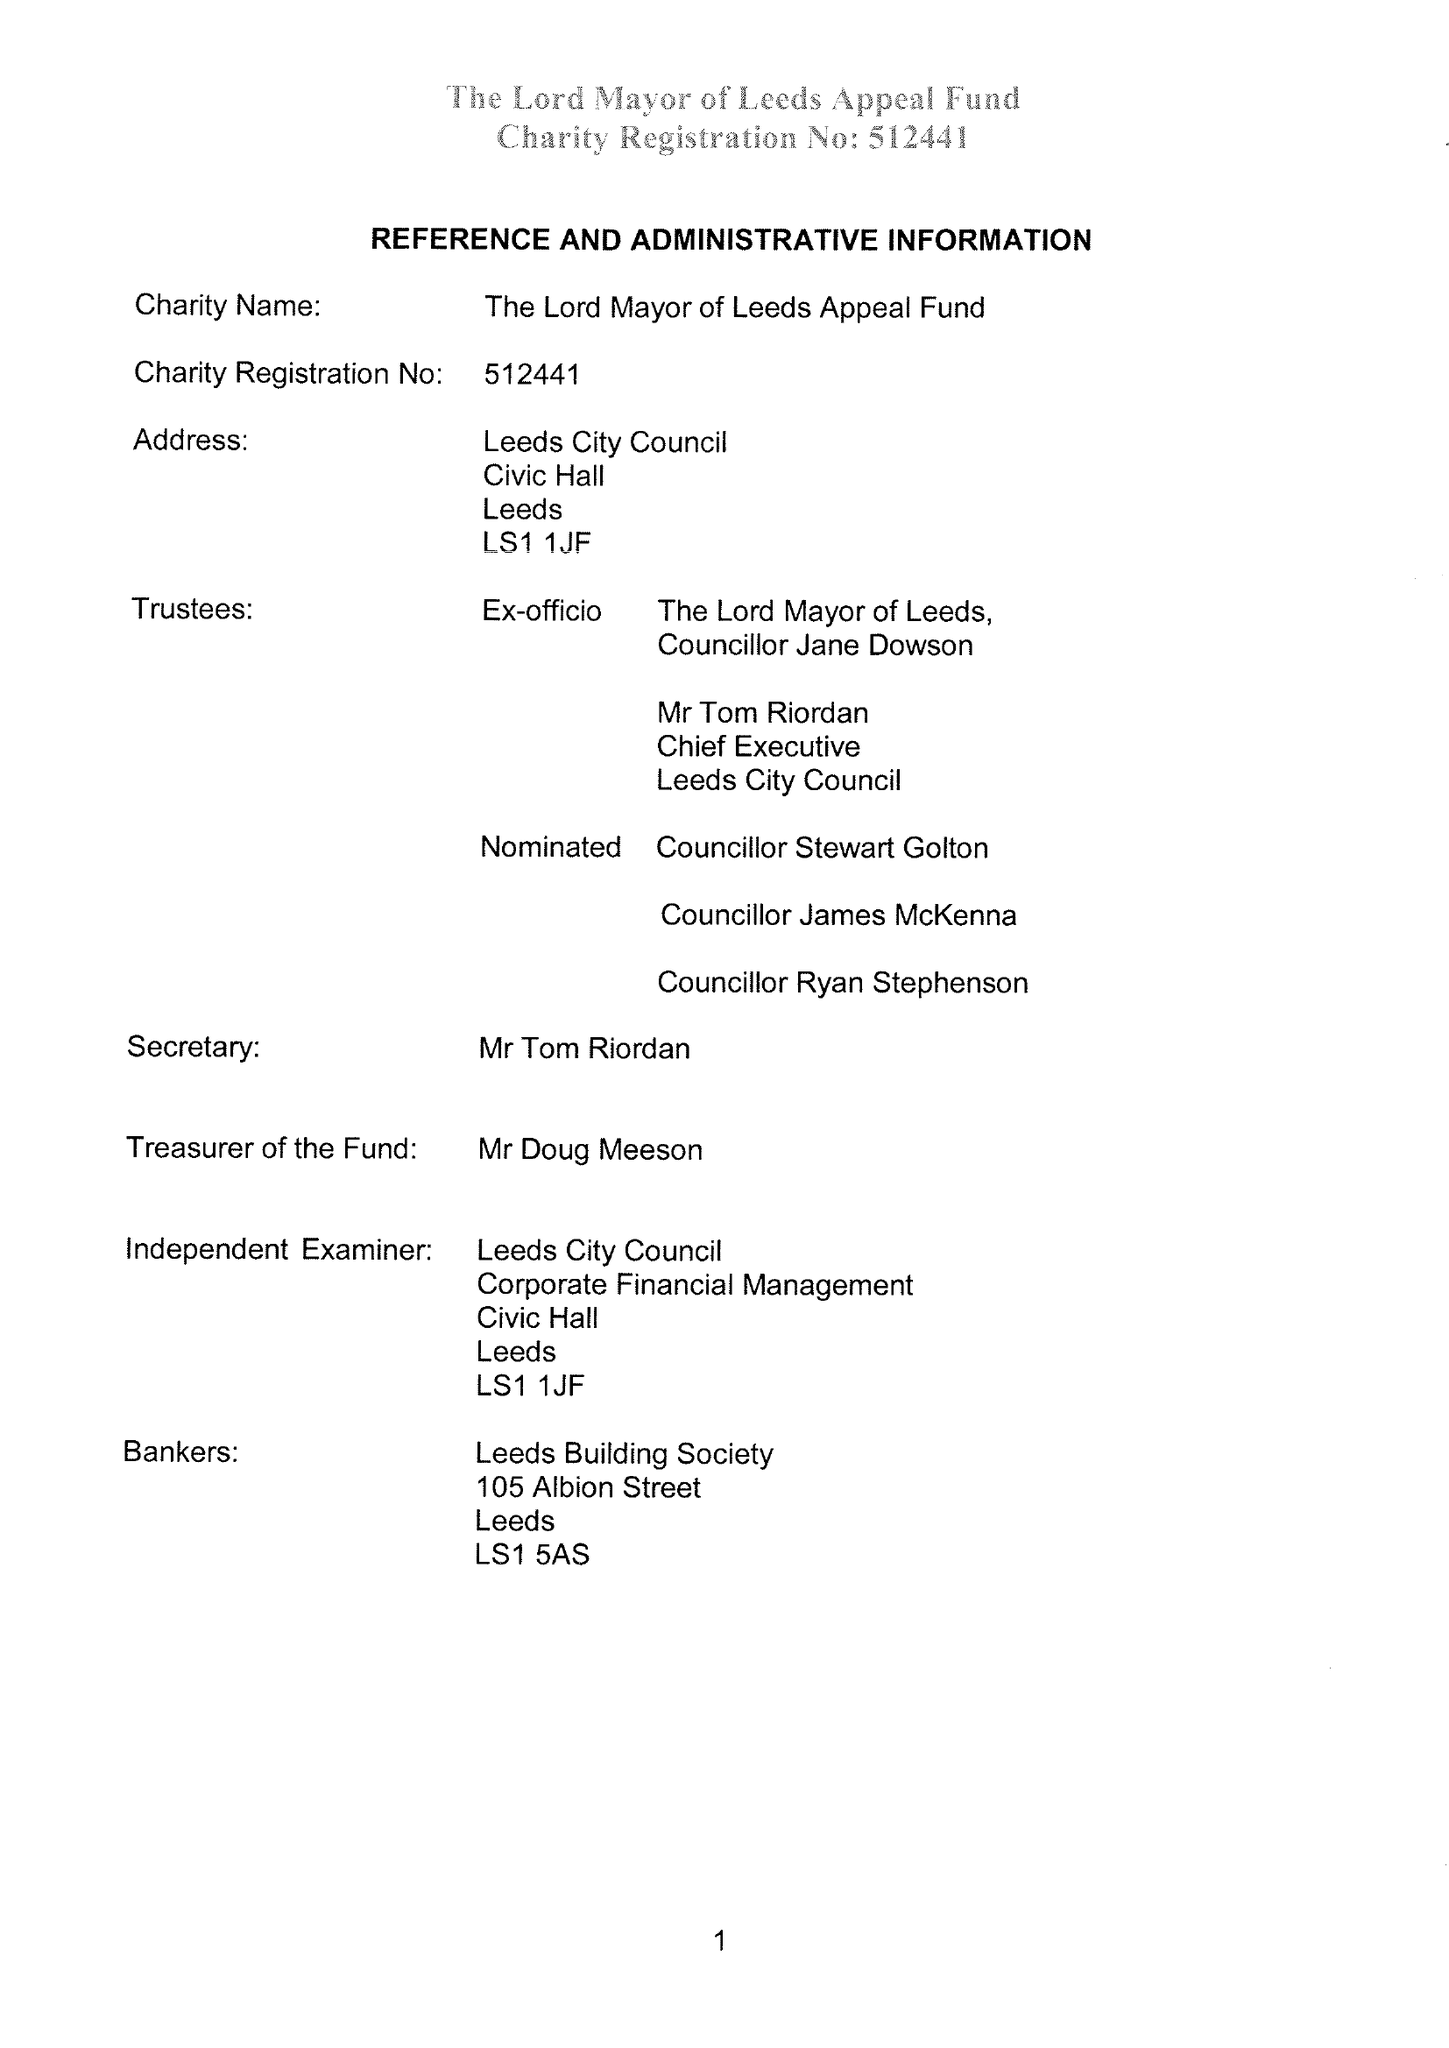What is the value for the charity_number?
Answer the question using a single word or phrase. 512441 